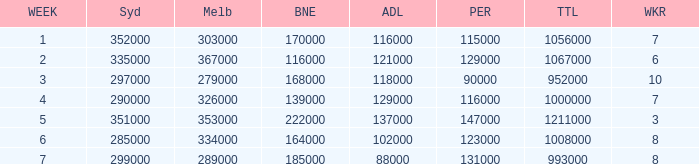Parse the full table. {'header': ['WEEK', 'Syd', 'Melb', 'BNE', 'ADL', 'PER', 'TTL', 'WKR'], 'rows': [['1', '352000', '303000', '170000', '116000', '115000', '1056000', '7'], ['2', '335000', '367000', '116000', '121000', '129000', '1067000', '6'], ['3', '297000', '279000', '168000', '118000', '90000', '952000', '10'], ['4', '290000', '326000', '139000', '129000', '116000', '1000000', '7'], ['5', '351000', '353000', '222000', '137000', '147000', '1211000', '3'], ['6', '285000', '334000', '164000', '102000', '123000', '1008000', '8'], ['7', '299000', '289000', '185000', '88000', '131000', '993000', '8']]} How many episodes aired in Sydney in Week 3? 1.0. 